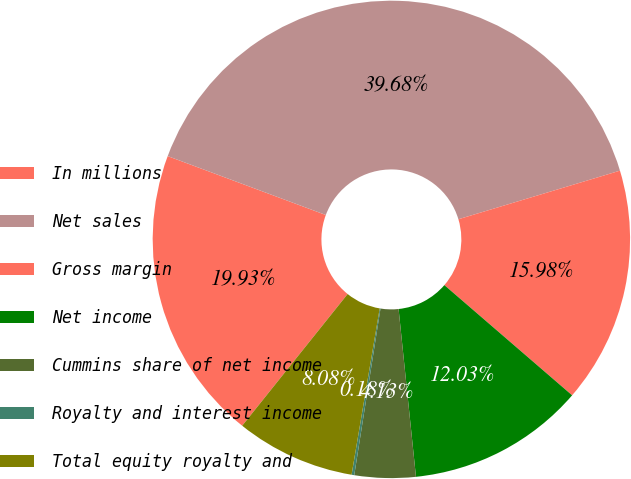<chart> <loc_0><loc_0><loc_500><loc_500><pie_chart><fcel>In millions<fcel>Net sales<fcel>Gross margin<fcel>Net income<fcel>Cummins share of net income<fcel>Royalty and interest income<fcel>Total equity royalty and<nl><fcel>19.93%<fcel>39.68%<fcel>15.98%<fcel>12.03%<fcel>4.13%<fcel>0.18%<fcel>8.08%<nl></chart> 